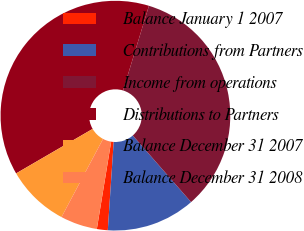<chart> <loc_0><loc_0><loc_500><loc_500><pie_chart><fcel>Balance January 1 2007<fcel>Contributions from Partners<fcel>Income from operations<fcel>Distributions to Partners<fcel>Balance December 31 2007<fcel>Balance December 31 2008<nl><fcel>1.53%<fcel>12.5%<fcel>33.84%<fcel>38.09%<fcel>8.84%<fcel>5.19%<nl></chart> 